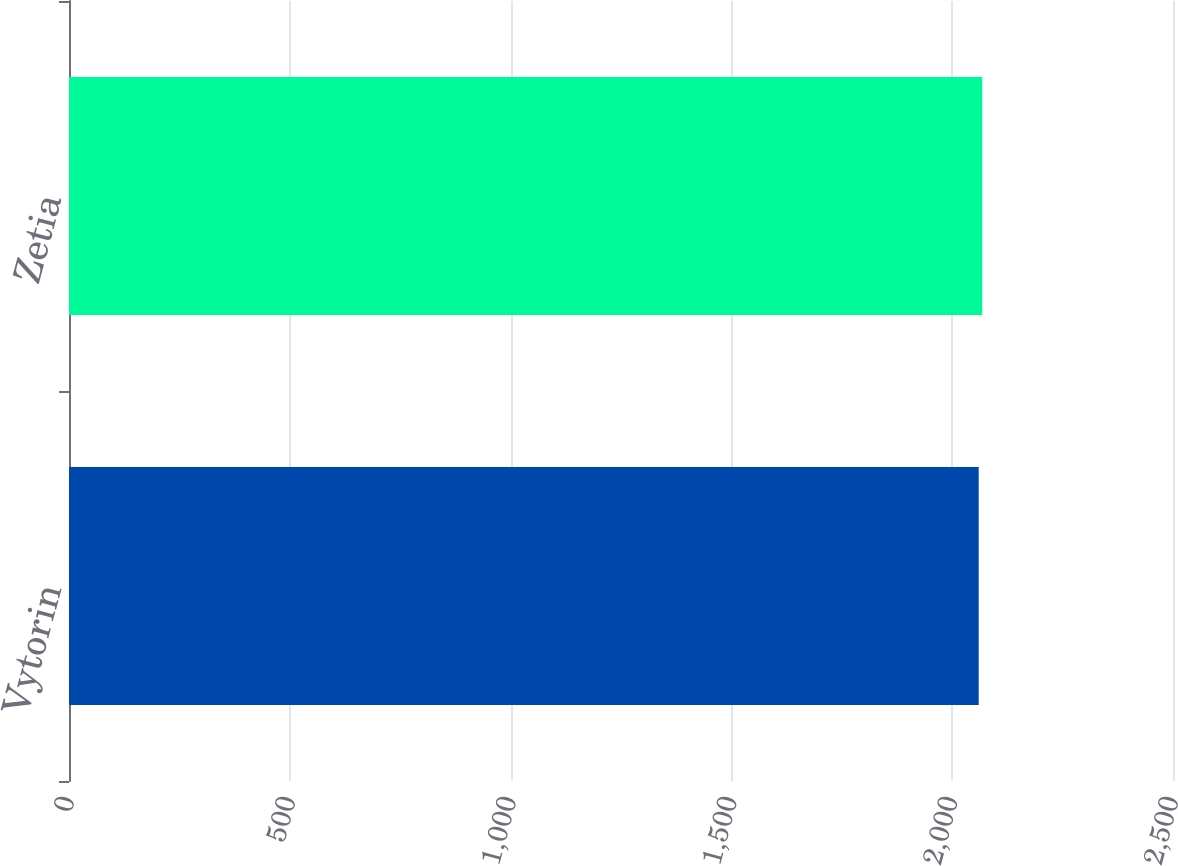<chart> <loc_0><loc_0><loc_500><loc_500><bar_chart><fcel>Vytorin<fcel>Zetia<nl><fcel>2060<fcel>2068<nl></chart> 